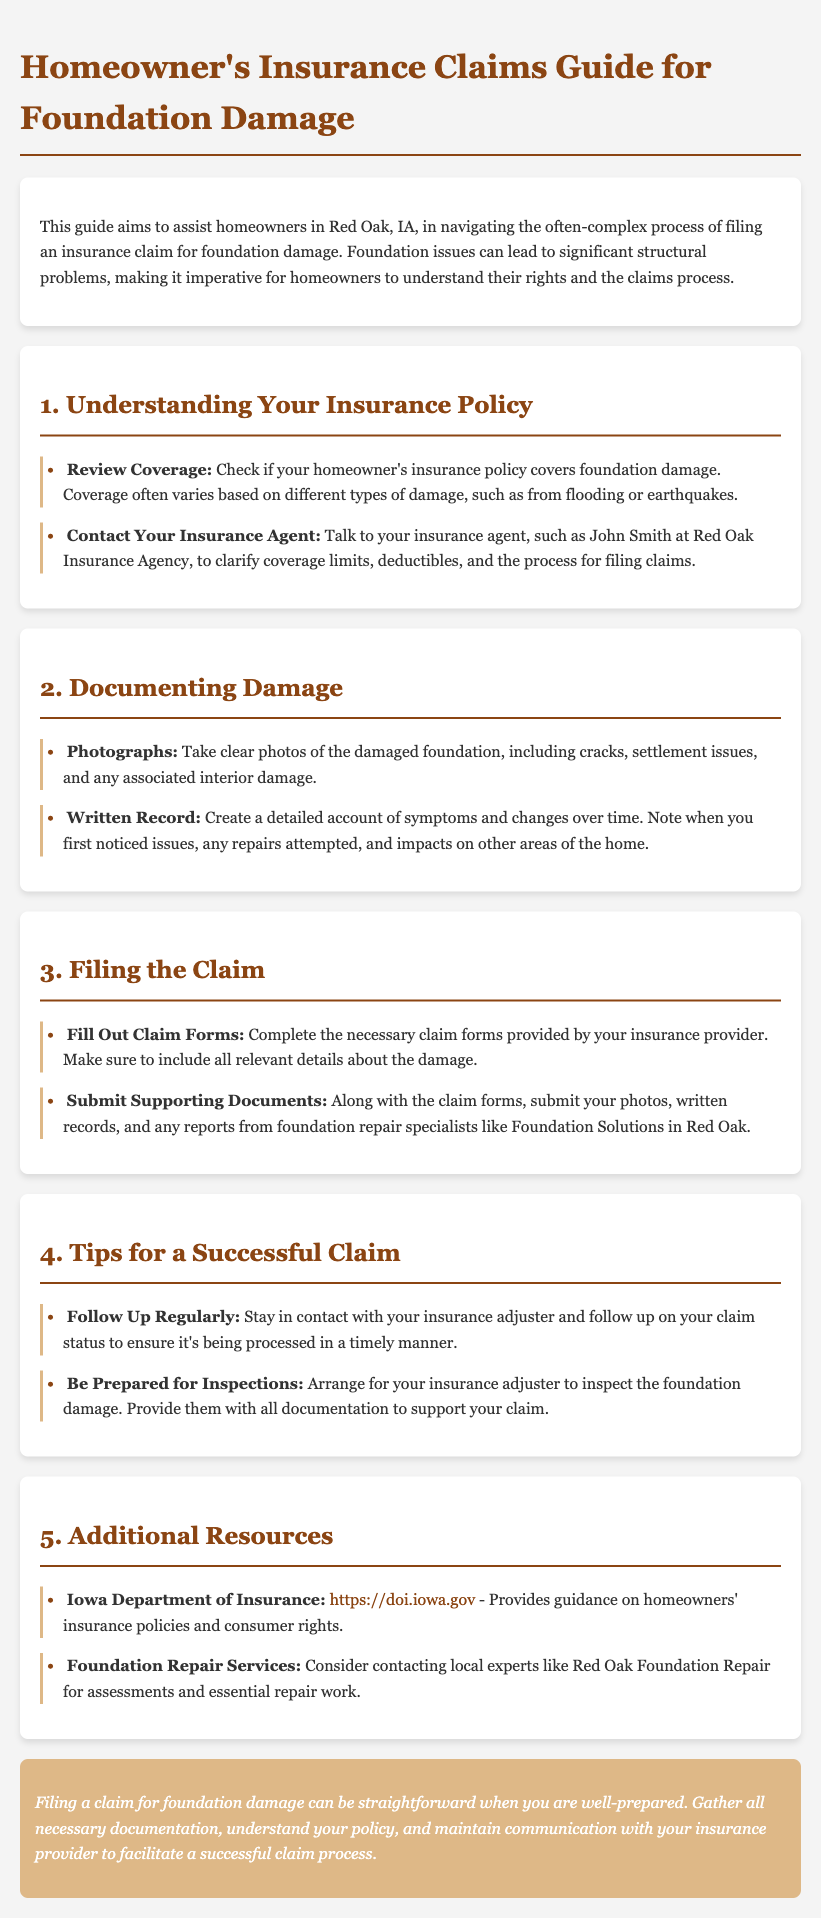What is the title of the guide? The title is located in the document's header and provides the main subject of the content.
Answer: Homeowner's Insurance Claims Guide for Foundation Damage Who should you contact for clarifying coverage limits? The document mentions a specific insurance agent who can assist homeowners in understanding their policy.
Answer: John Smith What should you take photos of to support your claim? This question pertains to the documentation process and is based on specific suggestions in the guide.
Answer: Damaged foundation What is a recommended action when filling out claim forms? This question explores best practices outlined in the claims process section of the document.
Answer: Include all relevant details What is a tip for ensuring timely processing of a claim? The guide offers proactive measures to keep a claim on track, involving ongoing communication.
Answer: Follow Up Regularly What is the resource provided for homeowners to understand their rights? This question identifies an organization linked to consumer protection mentioned in the document.
Answer: Iowa Department of Insurance What should be arranged for the insurance adjuster's visit? This focuses on preparation steps necessary for the inspection process related to claims.
Answer: Inspections What kind of documentation should be submitted along with the claim forms? This question looks into the necessary documents that help substantiate a claim.
Answer: Photos and written records 